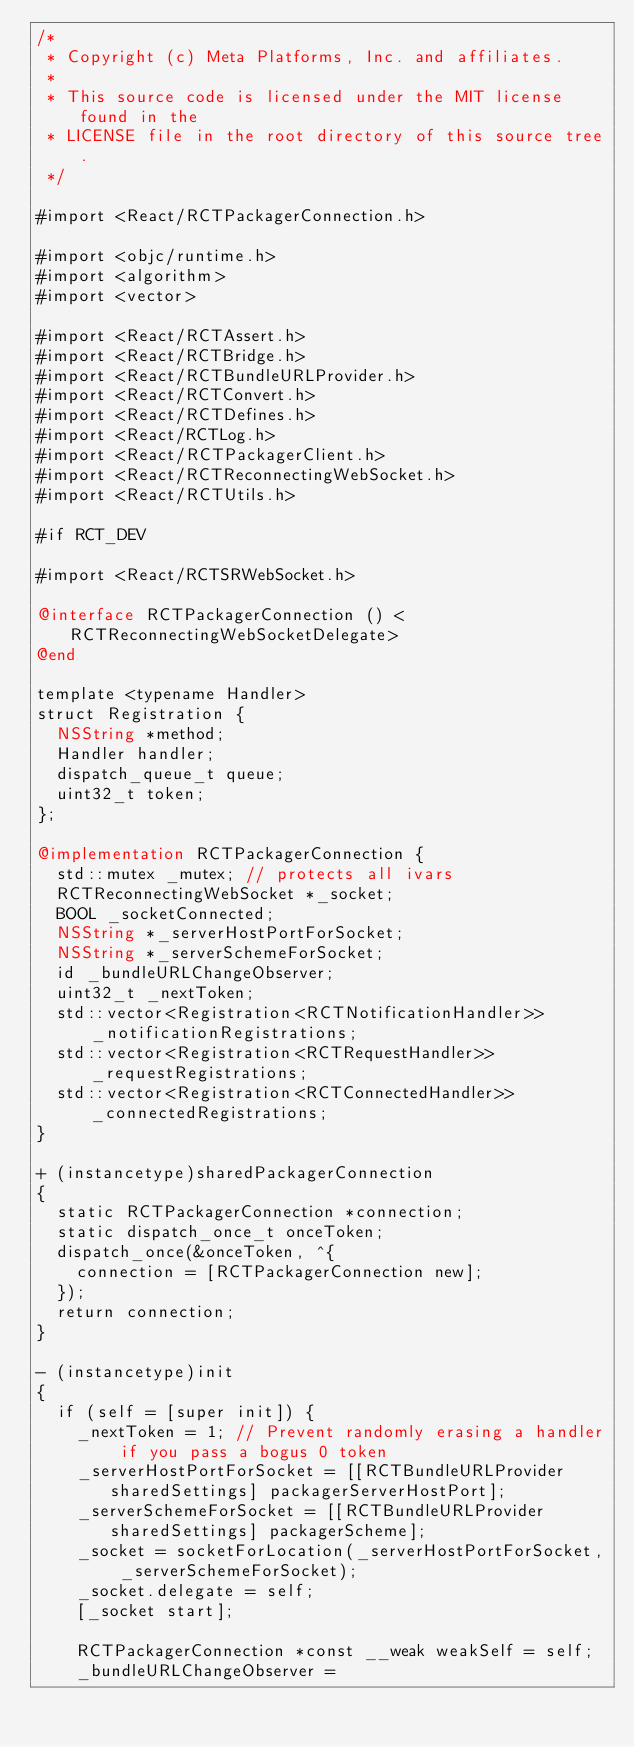Convert code to text. <code><loc_0><loc_0><loc_500><loc_500><_ObjectiveC_>/*
 * Copyright (c) Meta Platforms, Inc. and affiliates.
 *
 * This source code is licensed under the MIT license found in the
 * LICENSE file in the root directory of this source tree.
 */

#import <React/RCTPackagerConnection.h>

#import <objc/runtime.h>
#import <algorithm>
#import <vector>

#import <React/RCTAssert.h>
#import <React/RCTBridge.h>
#import <React/RCTBundleURLProvider.h>
#import <React/RCTConvert.h>
#import <React/RCTDefines.h>
#import <React/RCTLog.h>
#import <React/RCTPackagerClient.h>
#import <React/RCTReconnectingWebSocket.h>
#import <React/RCTUtils.h>

#if RCT_DEV

#import <React/RCTSRWebSocket.h>

@interface RCTPackagerConnection () <RCTReconnectingWebSocketDelegate>
@end

template <typename Handler>
struct Registration {
  NSString *method;
  Handler handler;
  dispatch_queue_t queue;
  uint32_t token;
};

@implementation RCTPackagerConnection {
  std::mutex _mutex; // protects all ivars
  RCTReconnectingWebSocket *_socket;
  BOOL _socketConnected;
  NSString *_serverHostPortForSocket;
  NSString *_serverSchemeForSocket;
  id _bundleURLChangeObserver;
  uint32_t _nextToken;
  std::vector<Registration<RCTNotificationHandler>> _notificationRegistrations;
  std::vector<Registration<RCTRequestHandler>> _requestRegistrations;
  std::vector<Registration<RCTConnectedHandler>> _connectedRegistrations;
}

+ (instancetype)sharedPackagerConnection
{
  static RCTPackagerConnection *connection;
  static dispatch_once_t onceToken;
  dispatch_once(&onceToken, ^{
    connection = [RCTPackagerConnection new];
  });
  return connection;
}

- (instancetype)init
{
  if (self = [super init]) {
    _nextToken = 1; // Prevent randomly erasing a handler if you pass a bogus 0 token
    _serverHostPortForSocket = [[RCTBundleURLProvider sharedSettings] packagerServerHostPort];
    _serverSchemeForSocket = [[RCTBundleURLProvider sharedSettings] packagerScheme];
    _socket = socketForLocation(_serverHostPortForSocket, _serverSchemeForSocket);
    _socket.delegate = self;
    [_socket start];

    RCTPackagerConnection *const __weak weakSelf = self;
    _bundleURLChangeObserver =</code> 